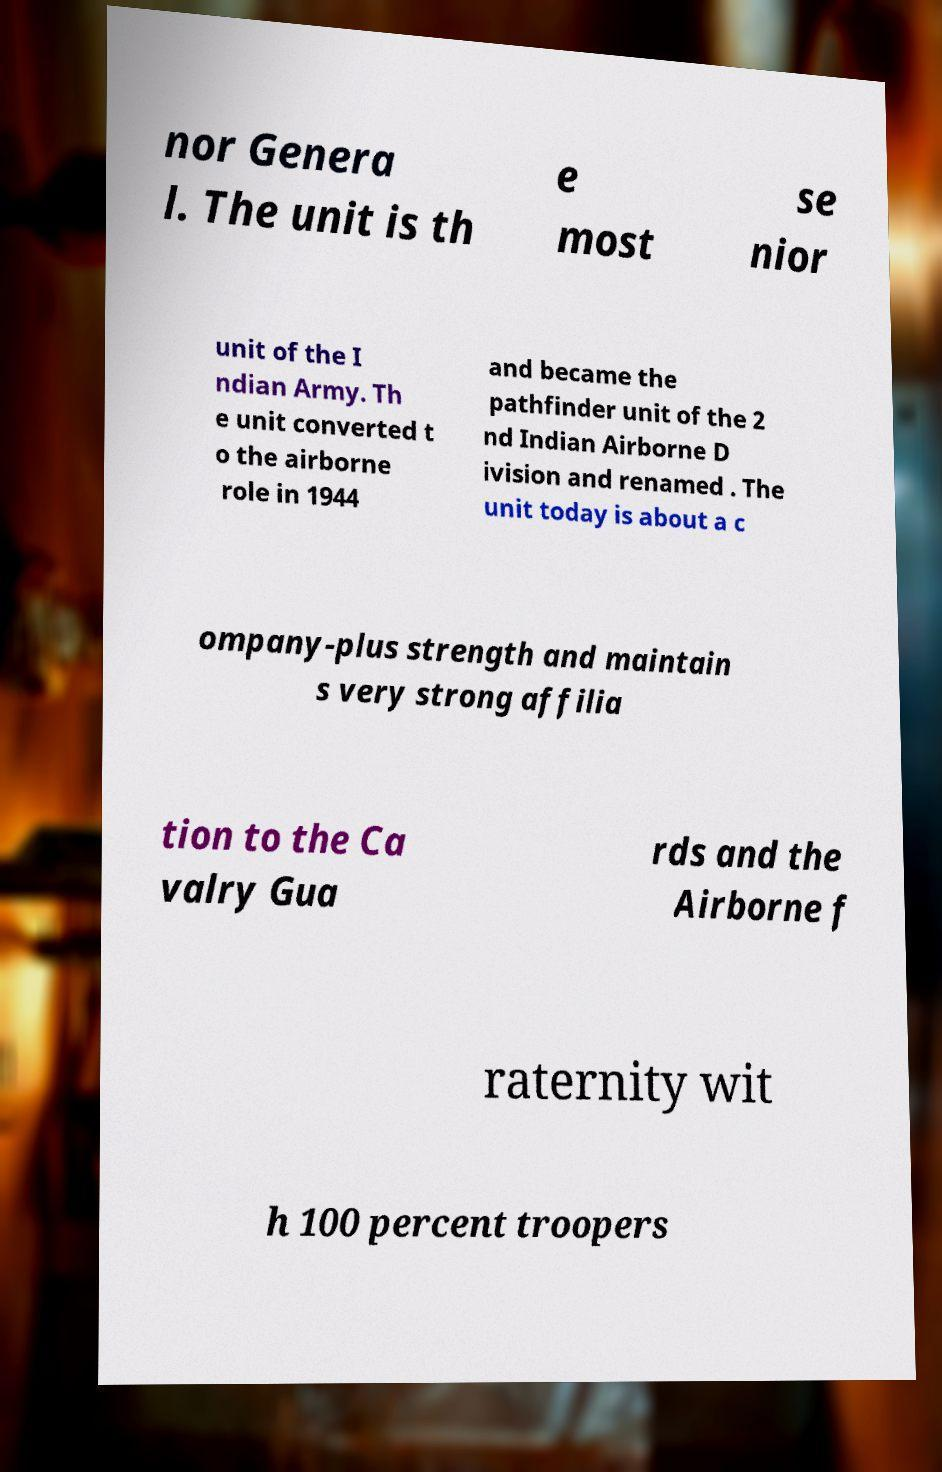Could you extract and type out the text from this image? nor Genera l. The unit is th e most se nior unit of the I ndian Army. Th e unit converted t o the airborne role in 1944 and became the pathfinder unit of the 2 nd Indian Airborne D ivision and renamed . The unit today is about a c ompany-plus strength and maintain s very strong affilia tion to the Ca valry Gua rds and the Airborne f raternity wit h 100 percent troopers 